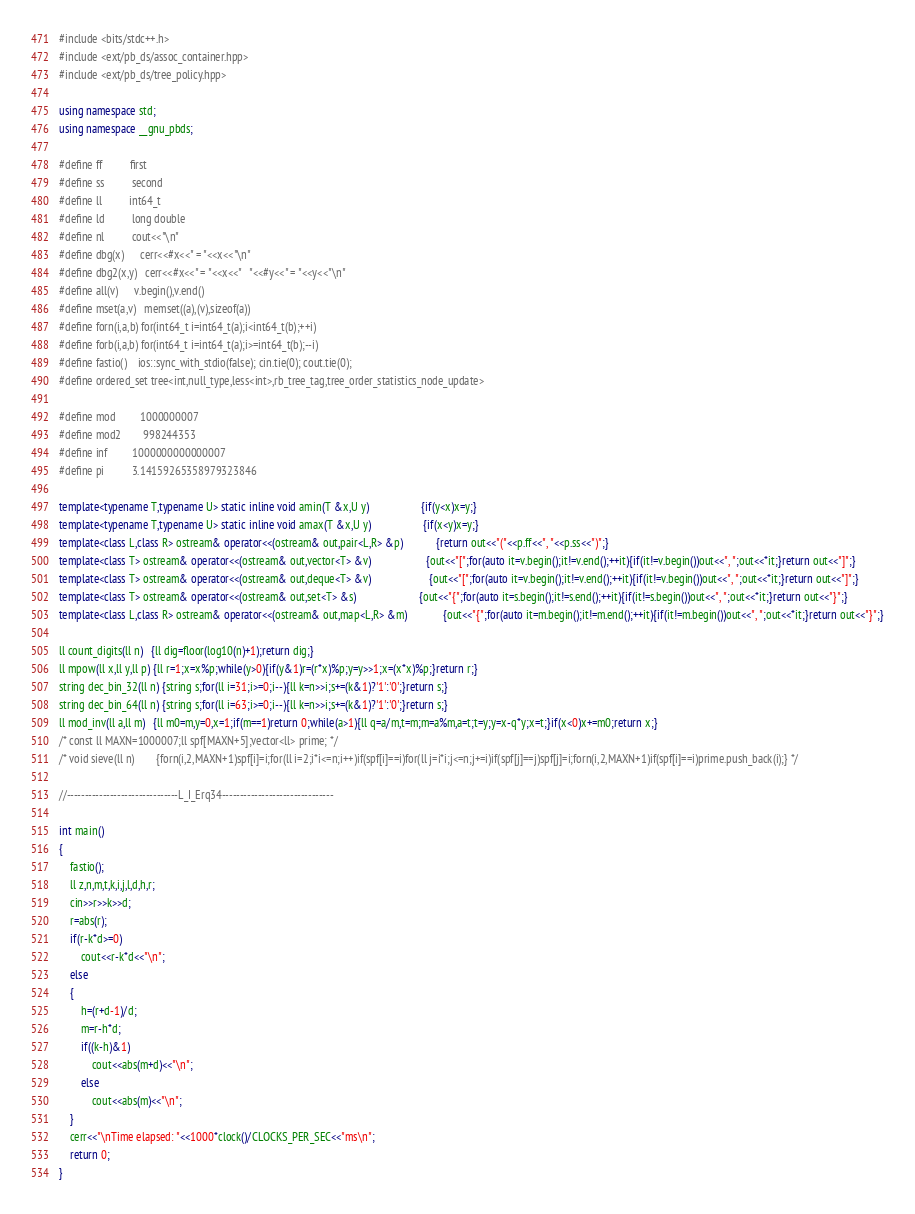Convert code to text. <code><loc_0><loc_0><loc_500><loc_500><_C++_>#include <bits/stdc++.h>
#include <ext/pb_ds/assoc_container.hpp>
#include <ext/pb_ds/tree_policy.hpp> 

using namespace std;
using namespace __gnu_pbds; 

#define ff          first
#define ss          second
#define ll          int64_t
#define ld          long double
#define nl          cout<<"\n"
#define dbg(x)      cerr<<#x<<" = "<<x<<"\n"
#define dbg2(x,y)   cerr<<#x<<" = "<<x<<"   "<<#y<<" = "<<y<<"\n"
#define all(v)      v.begin(),v.end()
#define mset(a,v)   memset((a),(v),sizeof(a))
#define forn(i,a,b) for(int64_t i=int64_t(a);i<int64_t(b);++i)
#define forb(i,a,b) for(int64_t i=int64_t(a);i>=int64_t(b);--i)
#define fastio()    ios::sync_with_stdio(false); cin.tie(0); cout.tie(0);
#define ordered_set tree<int,null_type,less<int>,rb_tree_tag,tree_order_statistics_node_update> 

#define mod         1000000007
#define mod2        998244353 
#define inf         1000000000000007
#define pi          3.14159265358979323846

template<typename T,typename U> static inline void amin(T &x,U y)                   {if(y<x)x=y;}
template<typename T,typename U> static inline void amax(T &x,U y)                   {if(x<y)x=y;}  
template<class L,class R> ostream& operator<<(ostream& out,pair<L,R> &p)            {return out<<"("<<p.ff<<", "<<p.ss<<")";}
template<class T> ostream& operator<<(ostream& out,vector<T> &v)                    {out<<"[";for(auto it=v.begin();it!=v.end();++it){if(it!=v.begin())out<<", ";out<<*it;}return out<<"]";}
template<class T> ostream& operator<<(ostream& out,deque<T> &v)                     {out<<"[";for(auto it=v.begin();it!=v.end();++it){if(it!=v.begin())out<<", ";out<<*it;}return out<<"]";}
template<class T> ostream& operator<<(ostream& out,set<T> &s)                       {out<<"{";for(auto it=s.begin();it!=s.end();++it){if(it!=s.begin())out<<", ";out<<*it;}return out<<"}";}
template<class L,class R> ostream& operator<<(ostream& out,map<L,R> &m)             {out<<"{";for(auto it=m.begin();it!=m.end();++it){if(it!=m.begin())out<<", ";out<<*it;}return out<<"}";}

ll count_digits(ll n)   {ll dig=floor(log10(n)+1);return dig;}
ll mpow(ll x,ll y,ll p) {ll r=1;x=x%p;while(y>0){if(y&1)r=(r*x)%p;y=y>>1;x=(x*x)%p;}return r;} 
string dec_bin_32(ll n) {string s;for(ll i=31;i>=0;i--){ll k=n>>i;s+=(k&1)?'1':'0';}return s;} 
string dec_bin_64(ll n) {string s;for(ll i=63;i>=0;i--){ll k=n>>i;s+=(k&1)?'1':'0';}return s;} 
ll mod_inv(ll a,ll m)   {ll m0=m,y=0,x=1;if(m==1)return 0;while(a>1){ll q=a/m,t=m;m=a%m,a=t;t=y;y=x-q*y;x=t;}if(x<0)x+=m0;return x;} 
/* const ll MAXN=1000007;ll spf[MAXN+5];vector<ll> prime; */
/* void sieve(ll n)        {forn(i,2,MAXN+1)spf[i]=i;for(ll i=2;i*i<=n;i++)if(spf[i]==i)for(ll j=i*i;j<=n;j+=i)if(spf[j]==j)spf[j]=i;forn(i,2,MAXN+1)if(spf[i]==i)prime.push_back(i);} */

//-------------------------------L_I_Erq34-------------------------------

int main()
{
	fastio();
	ll z,n,m,t,k,i,j,l,d,h,r;
	cin>>r>>k>>d;
	r=abs(r);
	if(r-k*d>=0)
		cout<<r-k*d<<"\n";
	else
	{
		h=(r+d-1)/d;
		m=r-h*d;
		if((k-h)&1)
			cout<<abs(m+d)<<"\n";
		else
			cout<<abs(m)<<"\n";
	}
	cerr<<"\nTime elapsed: "<<1000*clock()/CLOCKS_PER_SEC<<"ms\n";
	return 0;
}
</code> 